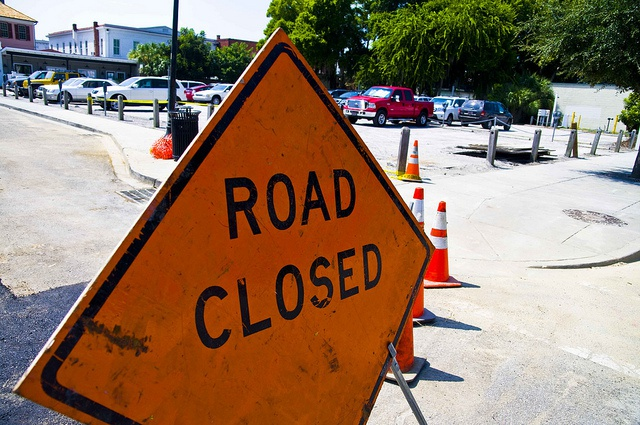Describe the objects in this image and their specific colors. I can see truck in black, maroon, white, and brown tones, car in black, lightblue, lavender, and darkgray tones, car in black, navy, blue, and gray tones, car in black, lavender, lightblue, and navy tones, and car in black, white, and darkgray tones in this image. 